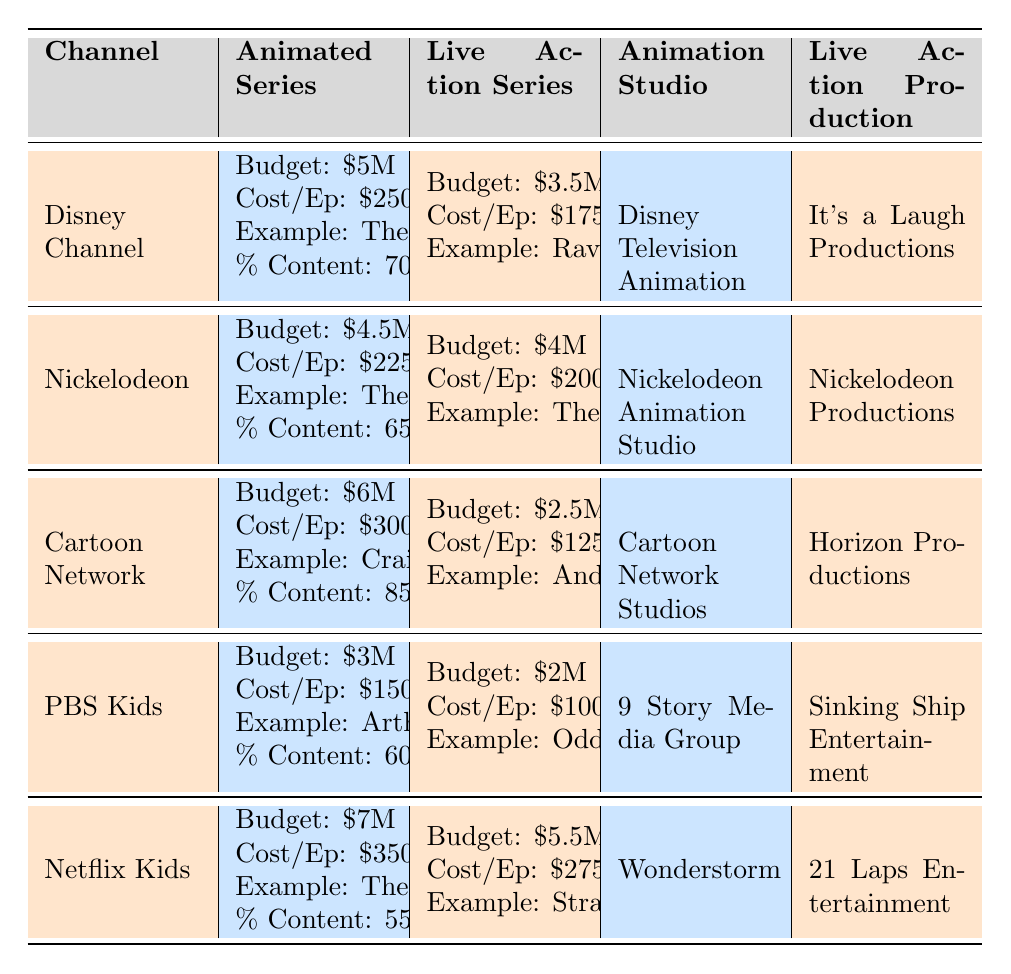What is the budget for the animated series on Netflix Kids? The table shows that the budget for the animated series on Netflix Kids is $7 million.
Answer: $7 million Which channel has the highest cost per episode for animated series? According to the table, Cartoon Network has the highest cost per episode for animated series at $300,000.
Answer: Cartoon Network What is the difference in budget between animated and live-action series on PBS Kids? The budget for PBS Kids' animated series is $3 million, while the live-action series budget is $2 million. The difference is $3 million - $2 million = $1 million.
Answer: $1 million True or False: The share of animated content is lower on Netflix Kids compared to PBS Kids. The percentage of animated content on Netflix Kids is 55%, while PBS Kids has 60%. Therefore, the statement is False.
Answer: False Which channel has the lowest budget for a live-action series, and what is that budget? Looking at the table, PBS Kids has the lowest budget for a live-action series at $2 million.
Answer: PBS Kids, $2 million What is the average cost per episode for live-action series across all channels? First, we sum the live-action cost per episode: 175,000 + 200,000 + 125,000 + 100,000 + 275,000 = 875,000. Then, we divide by the number of channels (5): 875,000 / 5 = 175,000.
Answer: $175,000 True or False: Animation studios associated with animated series are more expensive on average than live-action production companies. To check, we calculate the average budget for animated series ($5M + $4.5M + $6M + $3M + $7M) / 5 = $5.1M and for live-action series ($3.5M + $4M + $2.5M + $2M + $5.5M) / 5 = $3.5M. Since $5.1M > $3.5M, the statement is True.
Answer: True Which channel has the highest percentage of animated content? The table indicates that Cartoon Network has the highest percentage of animated content at 85%.
Answer: Cartoon Network What is the range of budgets for animated series among these channels? The range is calculated by subtracting the lowest budget ($3 million from PBS Kids) from the highest budget ($7 million from Netflix Kids): $7 million - $3 million = $4 million.
Answer: $4 million Which animated series example comes from Nickelodeon? According to the table, "The Loud House" is the animated series example from Nickelodeon.
Answer: The Loud House How many channels have an animated series budget greater than $5 million? From the table, Disney Channel, Cartoon Network, and Netflix Kids have animated series budgets greater than $5 million, totaling three channels.
Answer: 3 